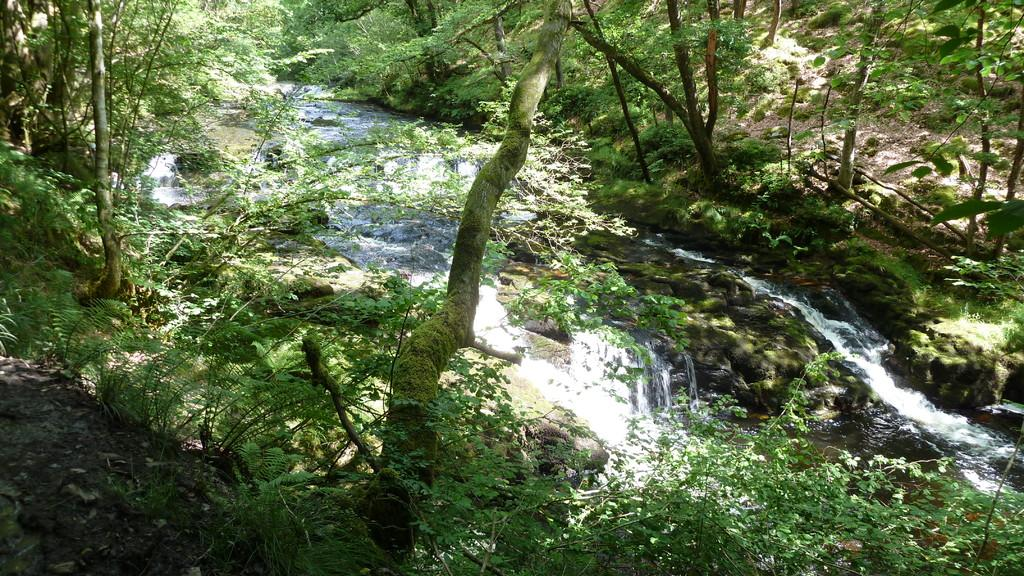What is the primary feature of the landscape in the image? There are many trees in the image. Can you describe the water feature in the image? Water is flowing near the trees in the image. How does the experience of digestion affect the trees in the image? There is no mention of digestion in the image, as it features trees and flowing water. What type of hook can be seen hanging from the trees in the image? There is no hook present in the image; it only features trees and flowing water. 